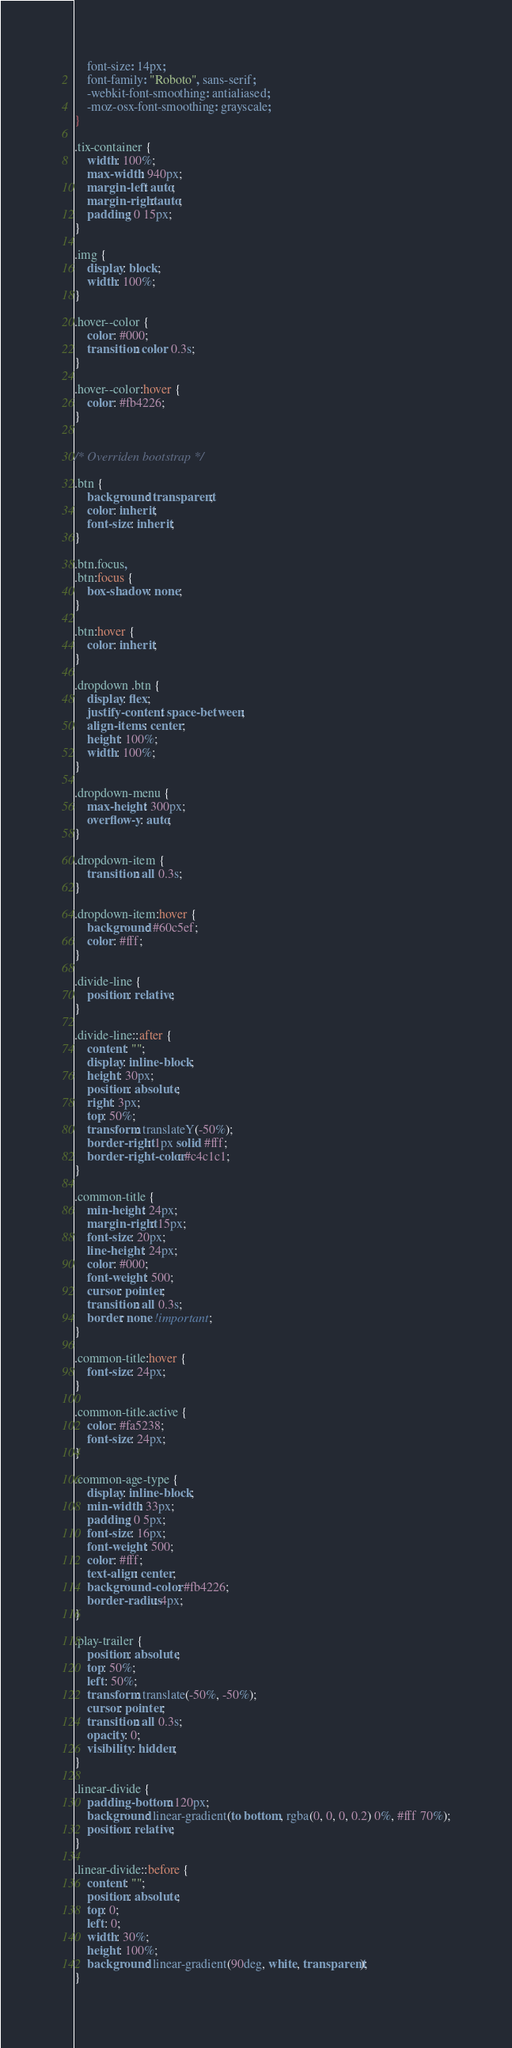Convert code to text. <code><loc_0><loc_0><loc_500><loc_500><_CSS_>    font-size: 14px;
    font-family: "Roboto", sans-serif;
    -webkit-font-smoothing: antialiased;
    -moz-osx-font-smoothing: grayscale;
}

.tix-container {
    width: 100%;
    max-width: 940px;
    margin-left: auto;
    margin-right: auto;
    padding: 0 15px;
}

.img {
    display: block;
    width: 100%;
}

.hover--color {
    color: #000;
    transition: color 0.3s;
}

.hover--color:hover {
    color: #fb4226;
}


/* Overriden bootstrap */

.btn {
    background: transparent;
    color: inherit;
    font-size: inherit;
}

.btn.focus,
.btn:focus {
    box-shadow: none;
}

.btn:hover {
    color: inherit;
}

.dropdown .btn {
    display: flex;
    justify-content: space-between;
    align-items: center;
    height: 100%;
    width: 100%;
}

.dropdown-menu {
    max-height: 300px;
    overflow-y: auto;
}

.dropdown-item {
    transition: all 0.3s;
}

.dropdown-item:hover {
    background: #60c5ef;
    color: #fff;
}

.divide-line {
    position: relative;
}

.divide-line::after {
    content: "";
    display: inline-block;
    height: 30px;
    position: absolute;
    right: 3px;
    top: 50%;
    transform: translateY(-50%);
    border-right: 1px solid #fff;
    border-right-color: #c4c1c1;
}

.common-title {
    min-height: 24px;
    margin-right: 15px;
    font-size: 20px;
    line-height: 24px;
    color: #000;
    font-weight: 500;
    cursor: pointer;
    transition: all 0.3s;
    border: none !important;
}

.common-title:hover {
    font-size: 24px;
}

.common-title.active {
    color: #fa5238;
    font-size: 24px;
}

.common-age-type {
    display: inline-block;
    min-width: 33px;
    padding: 0 5px;
    font-size: 16px;
    font-weight: 500;
    color: #fff;
    text-align: center;
    background-color: #fb4226;
    border-radius: 4px;
}

.play-trailer {
    position: absolute;
    top: 50%;
    left: 50%;
    transform: translate(-50%, -50%);
    cursor: pointer;
    transition: all 0.3s;
    opacity: 0;
    visibility: hidden;
}

.linear-divide {
    padding-bottom: 120px;
    background: linear-gradient(to bottom, rgba(0, 0, 0, 0.2) 0%, #fff 70%);
    position: relative;
}

.linear-divide::before {
    content: "";
    position: absolute;
    top: 0;
    left: 0;
    width: 30%;
    height: 100%;
    background: linear-gradient(90deg, white, transparent);
}
</code> 